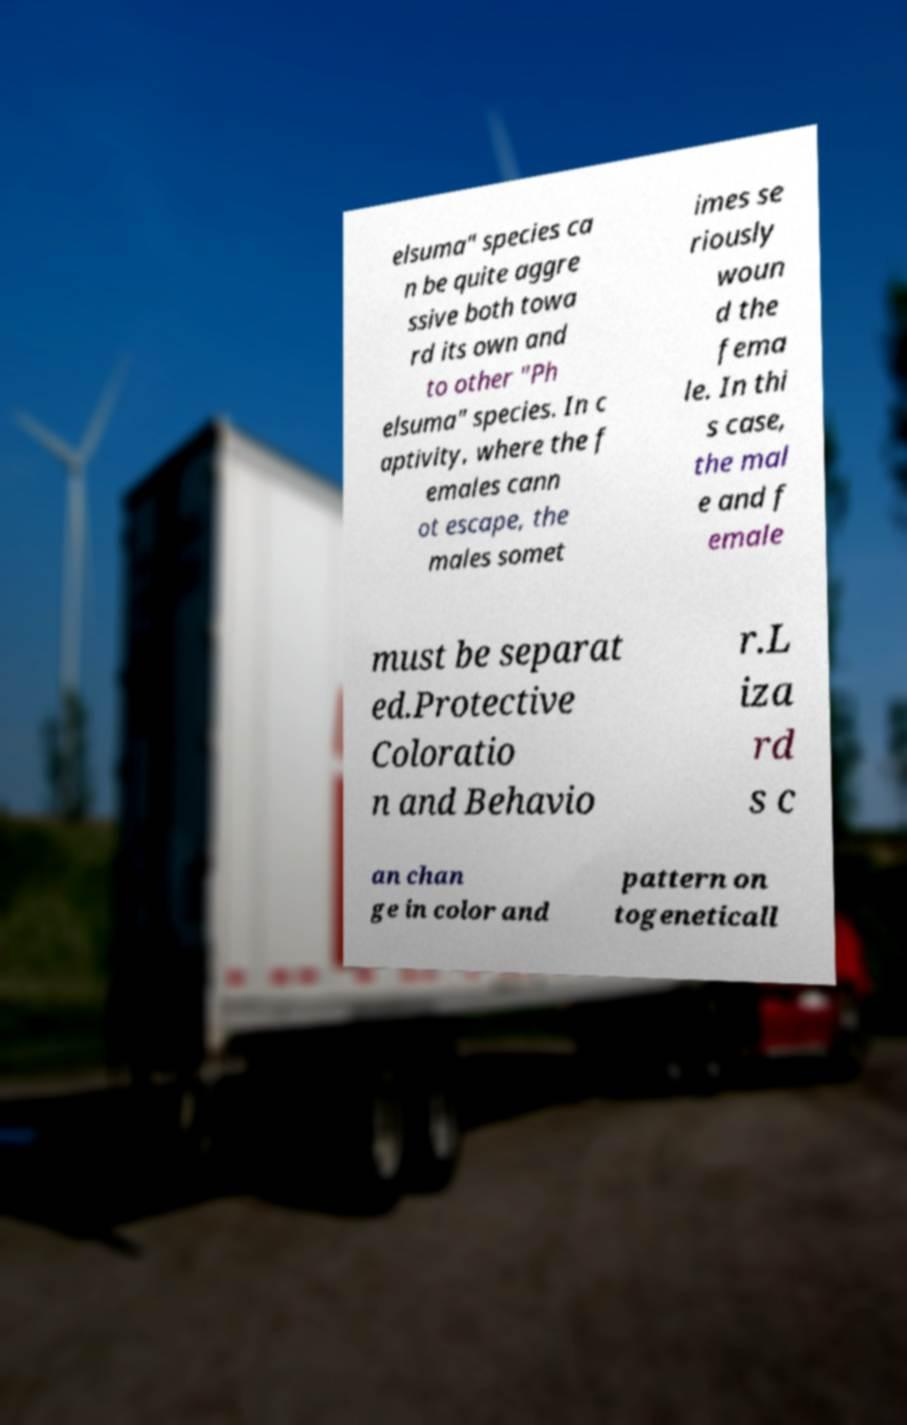I need the written content from this picture converted into text. Can you do that? elsuma" species ca n be quite aggre ssive both towa rd its own and to other "Ph elsuma" species. In c aptivity, where the f emales cann ot escape, the males somet imes se riously woun d the fema le. In thi s case, the mal e and f emale must be separat ed.Protective Coloratio n and Behavio r.L iza rd s c an chan ge in color and pattern on togeneticall 